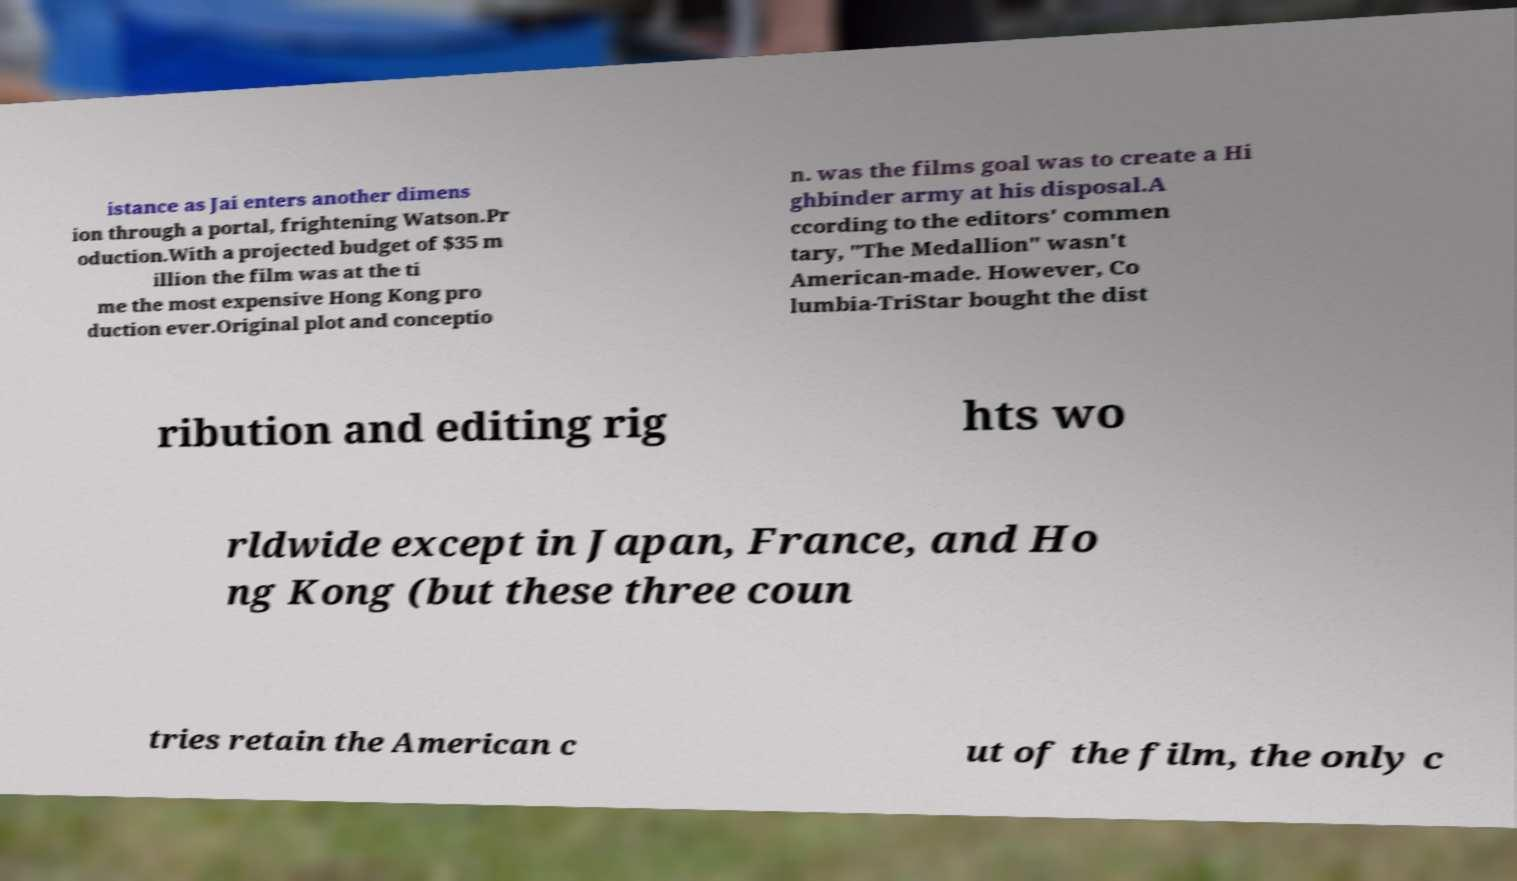Could you assist in decoding the text presented in this image and type it out clearly? istance as Jai enters another dimens ion through a portal, frightening Watson.Pr oduction.With a projected budget of $35 m illion the film was at the ti me the most expensive Hong Kong pro duction ever.Original plot and conceptio n. was the films goal was to create a Hi ghbinder army at his disposal.A ccording to the editors' commen tary, "The Medallion" wasn't American-made. However, Co lumbia-TriStar bought the dist ribution and editing rig hts wo rldwide except in Japan, France, and Ho ng Kong (but these three coun tries retain the American c ut of the film, the only c 